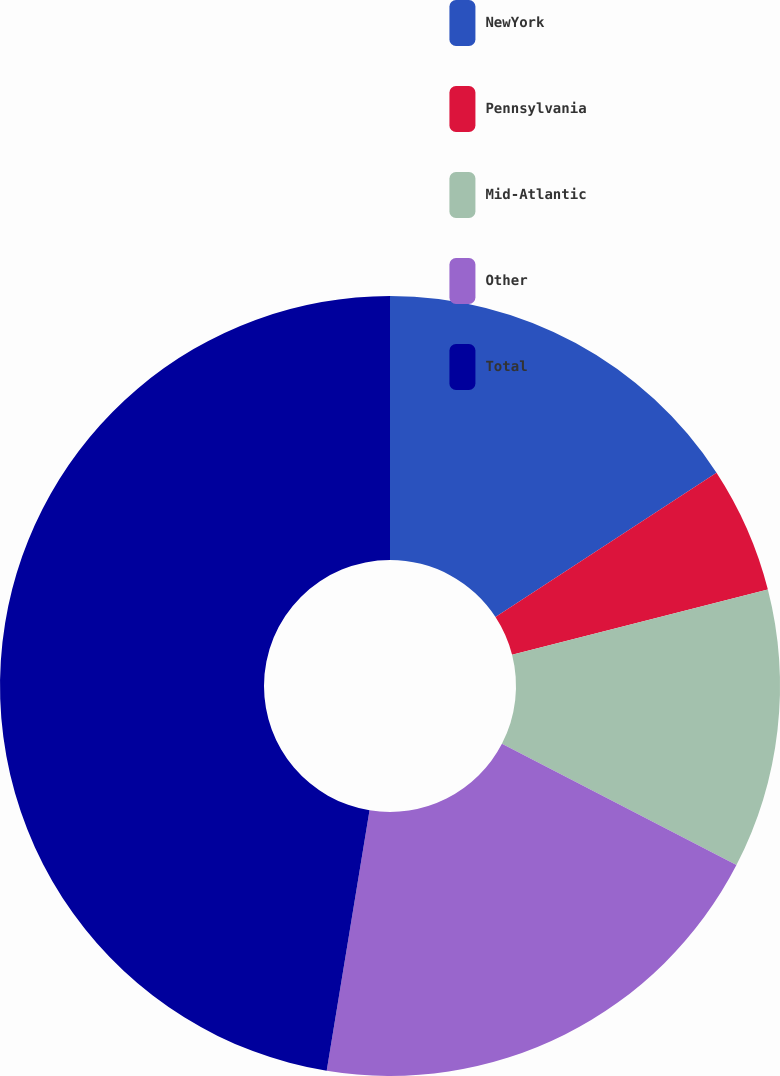Convert chart to OTSL. <chart><loc_0><loc_0><loc_500><loc_500><pie_chart><fcel>NewYork<fcel>Pennsylvania<fcel>Mid-Atlantic<fcel>Other<fcel>Total<nl><fcel>15.79%<fcel>5.23%<fcel>11.57%<fcel>20.0%<fcel>47.4%<nl></chart> 